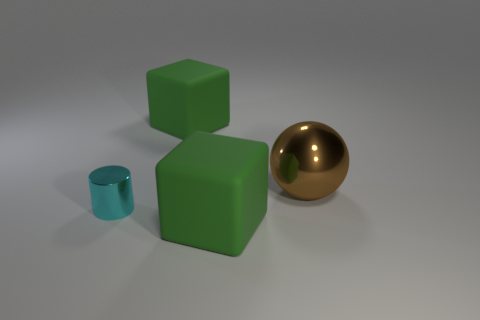Subtract 1 blocks. How many blocks are left? 1 Add 3 metal things. How many objects exist? 7 Subtract 0 blue blocks. How many objects are left? 4 Subtract all spheres. How many objects are left? 3 Subtract all blue spheres. Subtract all brown cubes. How many spheres are left? 1 Subtract all gray cylinders. How many cyan spheres are left? 0 Subtract all rubber blocks. Subtract all big matte things. How many objects are left? 0 Add 1 brown things. How many brown things are left? 2 Add 3 shiny cylinders. How many shiny cylinders exist? 4 